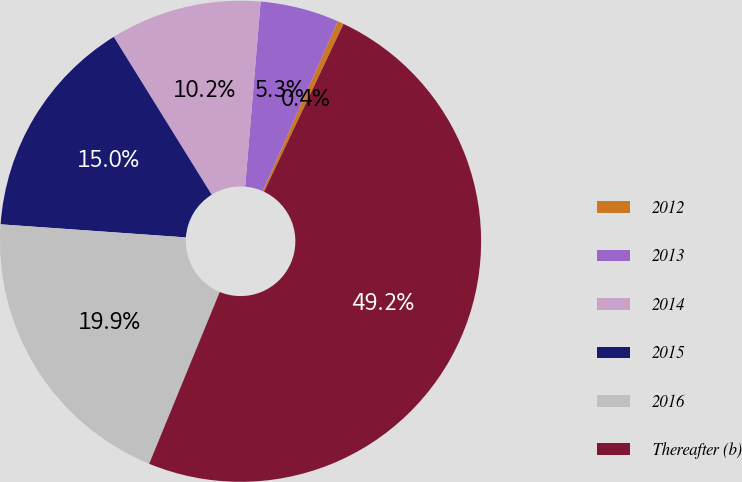<chart> <loc_0><loc_0><loc_500><loc_500><pie_chart><fcel>2012<fcel>2013<fcel>2014<fcel>2015<fcel>2016<fcel>Thereafter (b)<nl><fcel>0.42%<fcel>5.29%<fcel>10.17%<fcel>15.04%<fcel>19.92%<fcel>49.16%<nl></chart> 